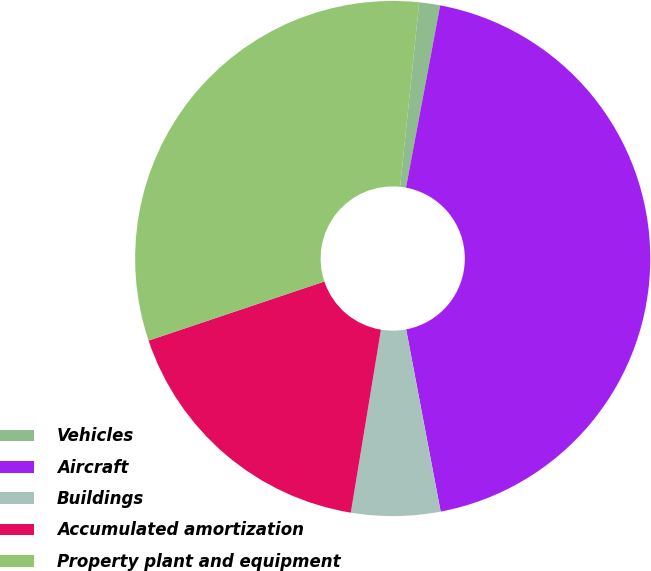Convert chart to OTSL. <chart><loc_0><loc_0><loc_500><loc_500><pie_chart><fcel>Vehicles<fcel>Aircraft<fcel>Buildings<fcel>Accumulated amortization<fcel>Property plant and equipment<nl><fcel>1.31%<fcel>44.07%<fcel>5.58%<fcel>17.24%<fcel>31.8%<nl></chart> 